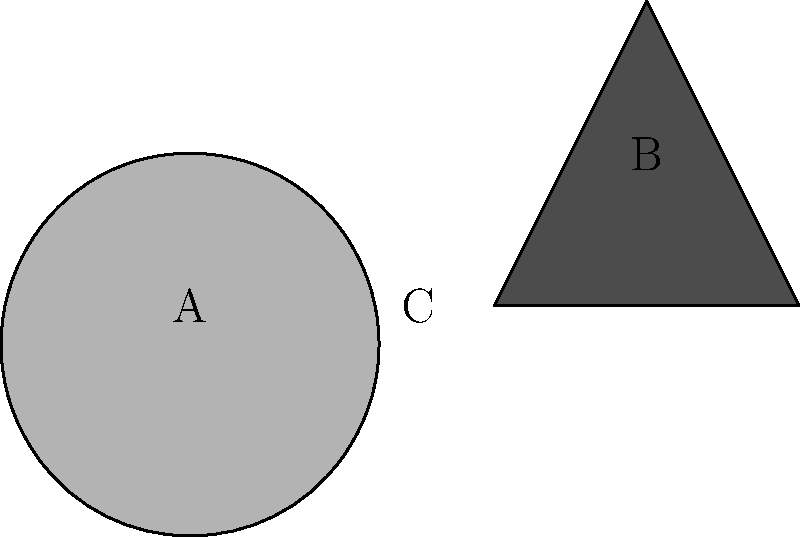In the image above, an African mask (A) and a paintbrush (B) are represented by simplified shapes. What letter denotes the area where these two cultural symbols overlap, creating a new silhouette that represents the intersection of traditional African art and contemporary artistic tools? To answer this question, we need to follow these steps:

1. Identify the two cultural symbols:
   a. The African mask (labeled A) is represented by the curved triangular shape on the left.
   b. The paintbrush (labeled B) is represented by the straight-edged triangular shape on the right.

2. Locate the area of overlap:
   The two shapes intersect in the middle, creating a new shape where they overlap.

3. Understand the significance:
   This overlapping area represents the intersection of traditional African art (symbolized by the mask) and contemporary artistic tools (symbolized by the paintbrush). It's a visual metaphor for the meeting of cultural heritage and modern artistic expression.

4. Identify the label:
   The area of overlap is clearly labeled with the letter C.

5. Interpret the meaning:
   The new silhouette created by this overlap (C) represents a space where traditional African art forms and contemporary artistic practices intersect, which is particularly relevant to the persona of an African American art critic focused on race and representation in art.
Answer: C 